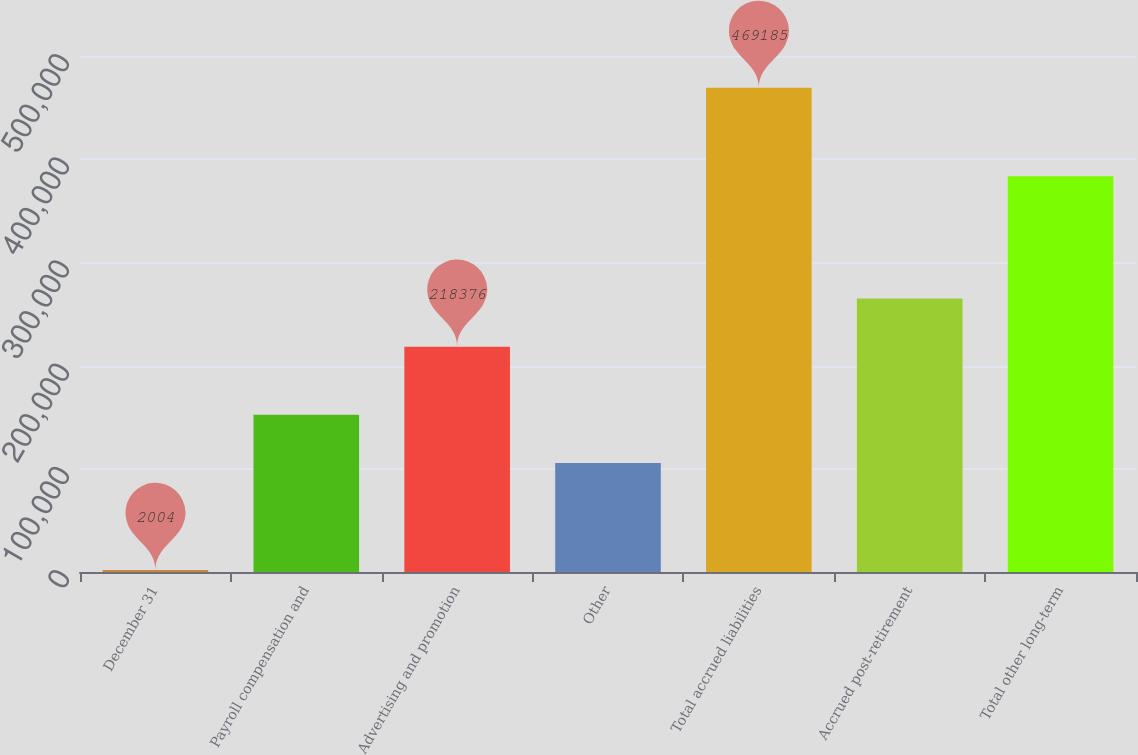<chart> <loc_0><loc_0><loc_500><loc_500><bar_chart><fcel>December 31<fcel>Payroll compensation and<fcel>Advertising and promotion<fcel>Other<fcel>Total accrued liabilities<fcel>Accrued post-retirement<fcel>Total other long-term<nl><fcel>2004<fcel>152404<fcel>218376<fcel>105686<fcel>469185<fcel>265094<fcel>383379<nl></chart> 